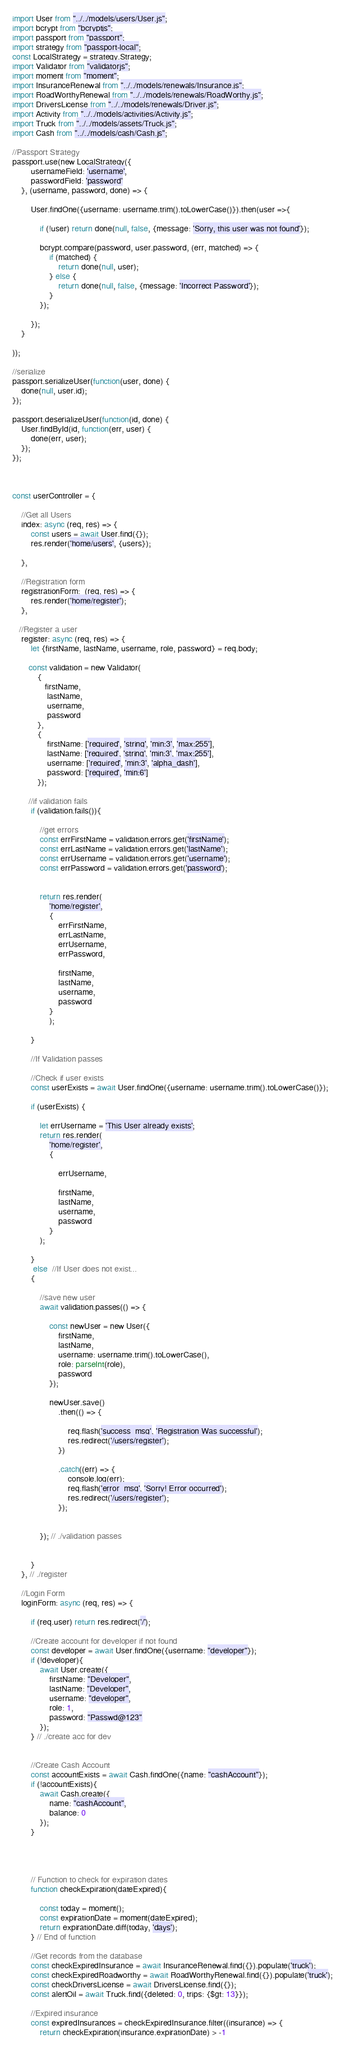Convert code to text. <code><loc_0><loc_0><loc_500><loc_500><_JavaScript_>import User from "../../models/users/User.js";
import bcrypt from "bcryptjs";
import passport from "passport";
import strategy from "passport-local";
const LocalStrategy = strategy.Strategy;
import Validator from "validatorjs";
import moment from "moment";
import InsuranceRenewal from "../../models/renewals/Insurance.js";
import RoadWorthyRenewal from "../../models/renewals/RoadWorthy.js";
import DriversLicense from "../../models/renewals/Driver.js";
import Activity from "../../models/activities/Activity.js";
import Truck from "../../models/assets/Truck.js";
import Cash from "../../models/cash/Cash.js";

//Passport Strategy
passport.use(new LocalStrategy({
        usernameField: 'username',
        passwordField: 'password'
    }, (username, password, done) => {

        User.findOne({username: username.trim().toLowerCase()}).then(user =>{

            if (!user) return done(null, false, {message: 'Sorry, this user was not found'});

            bcrypt.compare(password, user.password, (err, matched) => {
                if (matched) {
                    return done(null, user);
                } else {
                    return done(null, false, {message: 'Incorrect Password'});
                }
            });

        });
    }

));

//serialize
passport.serializeUser(function(user, done) {
    done(null, user.id);
});

passport.deserializeUser(function(id, done) {
    User.findById(id, function(err, user) {
        done(err, user);
    });
});



const userController = {

    //Get all Users
    index: async (req, res) => {
        const users = await User.find({});
        res.render('home/users', {users});

    },

    //Registration form
    registrationForm:  (req, res) => {
        res.render('home/register');
    },

   //Register a user
    register: async (req, res) => {
        let {firstName, lastName, username, role, password} = req.body;

       const validation = new Validator(
           {
              firstName,
               lastName,
               username,
               password
           },
           {
               firstName: ['required', 'string', 'min:3', 'max:255'],
               lastName: ['required', 'string', 'min:3', 'max:255'],
               username: ['required', 'min:3', 'alpha_dash'],
               password: ['required', 'min:6']
           });

       //if validation fails
        if (validation.fails()){

            //get errors
            const errFirstName = validation.errors.get('firstName');
            const errLastName = validation.errors.get('lastName');
            const errUsername = validation.errors.get('username');
            const errPassword = validation.errors.get('password');


            return res.render(
                'home/register',
                {
                    errFirstName,
                    errLastName,
                    errUsername,
                    errPassword,

                    firstName,
                    lastName,
                    username,
                    password
                }
                );

        }

        //If Validation passes

        //Check if user exists
        const userExists = await User.findOne({username: username.trim().toLowerCase()});

        if (userExists) {

            let errUsername = 'This User already exists';
            return res.render(
                'home/register',
                {

                    errUsername,

                    firstName,
                    lastName,
                    username,
                    password
                }
            );

        }
         else  //If User does not exist...
        {

            //save new user
            await validation.passes(() => {

                const newUser = new User({
                    firstName,
                    lastName,
                    username: username.trim().toLowerCase(),
                    role: parseInt(role),
                    password
                });

                newUser.save()
                    .then(() => {

                        req.flash('success_msg', 'Registration Was successful');
                        res.redirect('/users/register');
                    })

                    .catch((err) => {
                        console.log(err);
                        req.flash('error_msg', 'Sorry! Error occurred');
                        res.redirect('/users/register');
                    });


            }); // ./validation passes


        }
    }, // ./register

    //Login Form
    loginForm: async (req, res) => {

        if (req.user) return res.redirect('/');

        //Create account for developer if not found
        const developer = await User.findOne({username: "developer"});
        if (!developer){
            await User.create({
                firstName: "Developer",
                lastName: "Developer",
                username: "developer",
                role: 1,
                password: "Passwd@123"
            });
        } // ./create acc for dev


        //Create Cash Account
        const accountExists = await Cash.findOne({name: "cashAccount"});
        if (!accountExists){
            await Cash.create({
                name: "cashAccount",
                balance: 0
            });
        }




        // Function to check for expiration dates
        function checkExpiration(dateExpired){

            const today = moment();
            const expirationDate = moment(dateExpired);
            return expirationDate.diff(today, 'days');
        } // End of function

        //Get records from the database
        const checkExpiredInsurance = await InsuranceRenewal.find({}).populate('truck');
        const checkExpiredRoadworthy = await RoadWorthyRenewal.find({}).populate('truck');
        const checkDriversLicense = await DriversLicense.find({});
        const alertOil = await Truck.find({deleted: 0, trips: {$gt: 13}});

        //Expired insurance
        const expiredInsurances = checkExpiredInsurance.filter((insurance) => {
            return checkExpiration(insurance.expirationDate) > -1</code> 